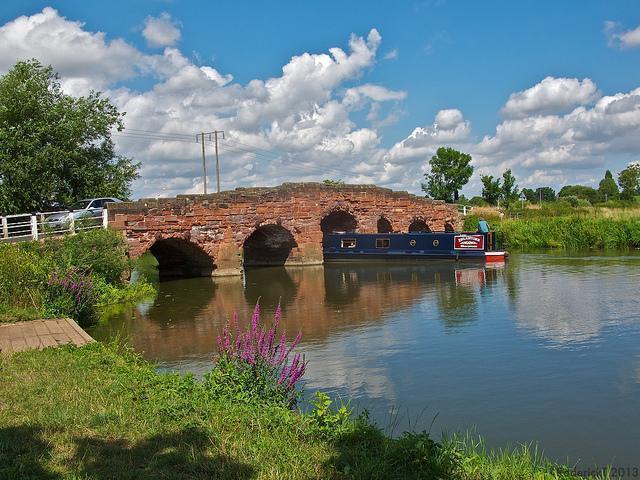Where is the boat going?
Make your selection from the four choices given to correctly answer the question.
Options: Over bridge, home, under bridge, up river. Under bridge. 